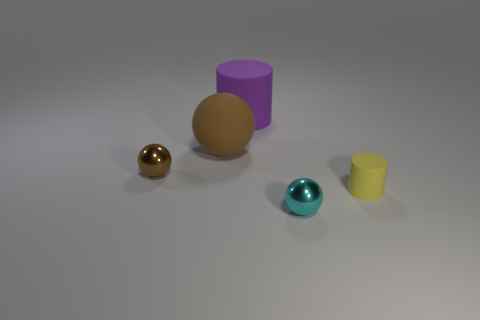Add 1 big gray spheres. How many objects exist? 6 Subtract all spheres. How many objects are left? 2 Subtract 0 red cubes. How many objects are left? 5 Subtract all rubber things. Subtract all tiny gray metal objects. How many objects are left? 2 Add 5 tiny brown shiny balls. How many tiny brown shiny balls are left? 6 Add 1 purple matte cylinders. How many purple matte cylinders exist? 2 